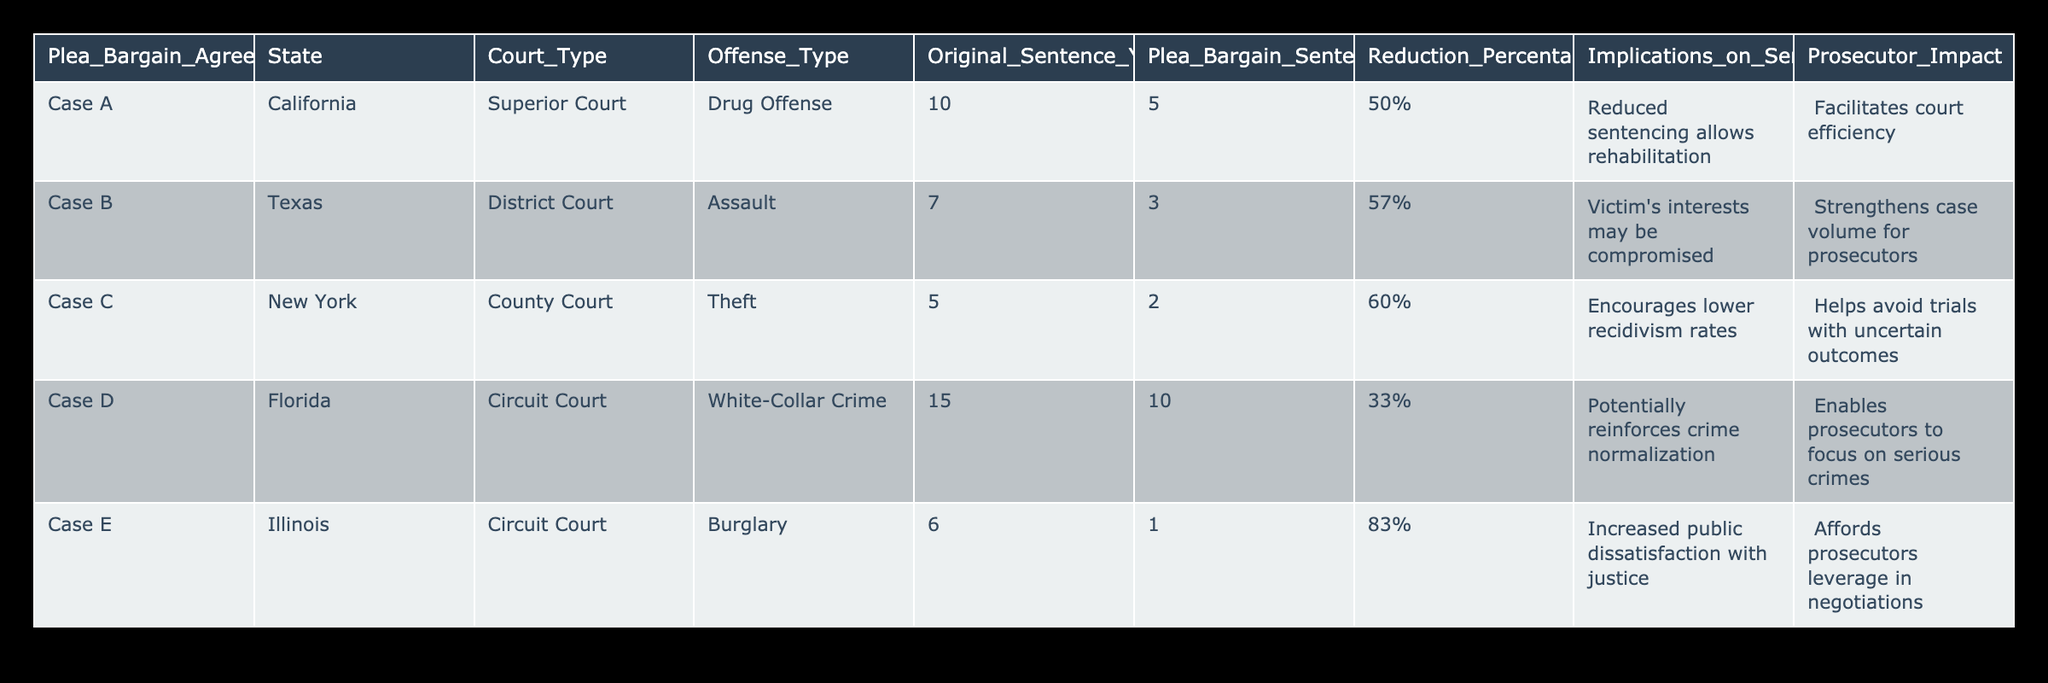What is the plea bargain sentence for Case A in California? The table lists the plea bargain agreement for Case A in California under the column "Plea Bargain Sentence Years," which shows a value of 5 years.
Answer: 5 years Which case has the highest percentage of sentence reduction? By inspecting the "Reduction Percentage" column, Case E shows a value of 83%, which is higher than all other cases listed.
Answer: Case E Is there any case where the implications on sentencing state that it "Enables prosecutors to focus on serious crimes"? Looking at the "Implications on Sentencing" column, Case D's implication states "Enables prosecutors to focus on serious crimes." Thus, the answer is yes.
Answer: Yes What is the average original sentence (in years) across all cases? To find the average, we add the original sentences: (10 + 7 + 5 + 15 + 6) = 43 years. There are five cases, so the average is 43/5 = 8.6 years.
Answer: 8.6 years Does the plea bargain sentence for Case B compromise the victim's interests? The implication for Case B explicitly mentions that "Victim's interests may be compromised," confirming it states this fact. Therefore, the answer is yes.
Answer: Yes Which case has the lowest plea bargain sentence and what is the reduction percentage? Looking through the "Plea Bargain Sentence Years," Case E has the lowest sentence of 1 year with a "Reduction Percentage" of 83%.
Answer: Case E, 83% What is the total number of years reduced from the original sentences across all cases? We calculate the reduction for each case by subtracting the plea bargain sentence from the original sentence: (10-5) + (7-3) + (5-2) + (15-10) + (6-1) = 5 + 4 + 3 + 5 + 5 = 22 years reduced in total.
Answer: 22 years What court type is involved in Case C and what is the offense type? According to the table, Case C in New York has "County Court" as the court type and "Theft" as the offense type.
Answer: County Court, Theft Is it true that all cases listed mention an implication related to improving court efficiency? Reviewing the "Implications on Sentencing" column, while Case A states "Facilitates court efficiency," not all cases have this implication, indicating that this statement is not universally true.
Answer: No 